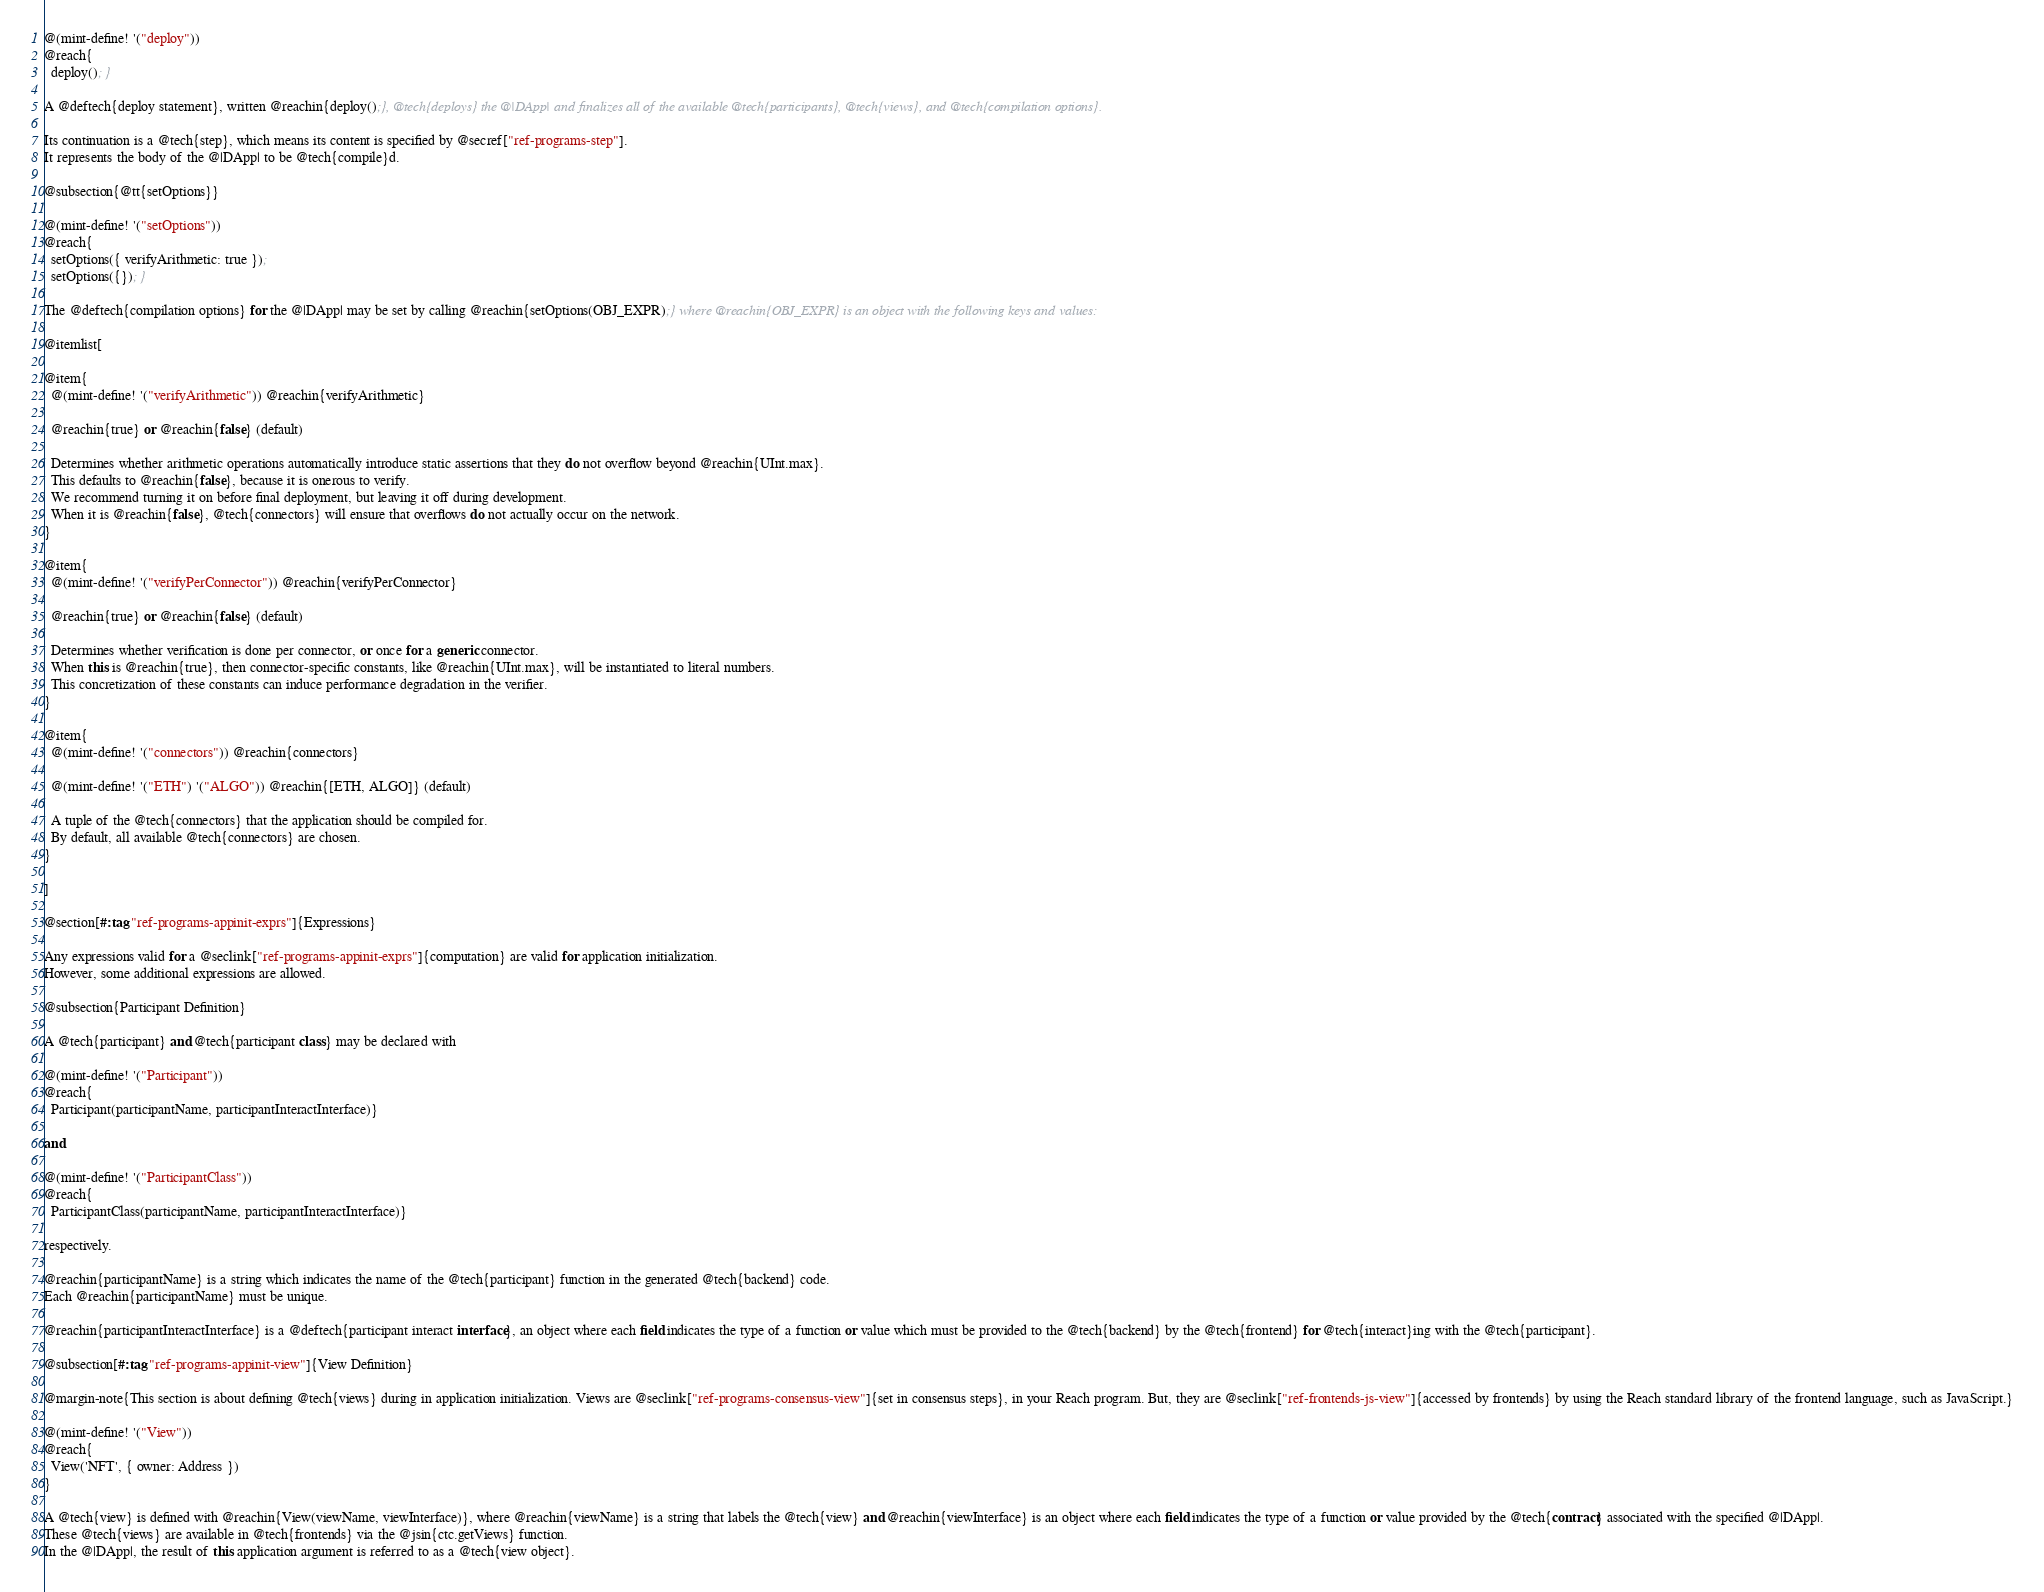Convert code to text. <code><loc_0><loc_0><loc_500><loc_500><_Racket_>@(mint-define! '("deploy"))
@reach{
  deploy(); }

A @deftech{deploy statement}, written @reachin{deploy();}, @tech{deploys} the @|DApp| and finalizes all of the available @tech{participants}, @tech{views}, and @tech{compilation options}.

Its continuation is a @tech{step}, which means its content is specified by @secref["ref-programs-step"].
It represents the body of the @|DApp| to be @tech{compile}d.

@subsection{@tt{setOptions}}

@(mint-define! '("setOptions"))
@reach{
  setOptions({ verifyArithmetic: true });
  setOptions({}); }

The @deftech{compilation options} for the @|DApp| may be set by calling @reachin{setOptions(OBJ_EXPR);} where @reachin{OBJ_EXPR} is an object with the following keys and values:

@itemlist[

@item{
  @(mint-define! '("verifyArithmetic")) @reachin{verifyArithmetic}

  @reachin{true} or @reachin{false} (default)

  Determines whether arithmetic operations automatically introduce static assertions that they do not overflow beyond @reachin{UInt.max}.
  This defaults to @reachin{false}, because it is onerous to verify.
  We recommend turning it on before final deployment, but leaving it off during development.
  When it is @reachin{false}, @tech{connectors} will ensure that overflows do not actually occur on the network.
}

@item{
  @(mint-define! '("verifyPerConnector")) @reachin{verifyPerConnector}

  @reachin{true} or @reachin{false} (default)

  Determines whether verification is done per connector, or once for a generic connector.
  When this is @reachin{true}, then connector-specific constants, like @reachin{UInt.max}, will be instantiated to literal numbers.
  This concretization of these constants can induce performance degradation in the verifier.
}

@item{
  @(mint-define! '("connectors")) @reachin{connectors}

  @(mint-define! '("ETH") '("ALGO")) @reachin{[ETH, ALGO]} (default)

  A tuple of the @tech{connectors} that the application should be compiled for.
  By default, all available @tech{connectors} are chosen.
}

]

@section[#:tag "ref-programs-appinit-exprs"]{Expressions}

Any expressions valid for a @seclink["ref-programs-appinit-exprs"]{computation} are valid for application initialization.
However, some additional expressions are allowed.

@subsection{Participant Definition}

A @tech{participant} and @tech{participant class} may be declared with

@(mint-define! '("Participant"))
@reach{
  Participant(participantName, participantInteractInterface)}

and

@(mint-define! '("ParticipantClass"))
@reach{
  ParticipantClass(participantName, participantInteractInterface)}

respectively.

@reachin{participantName} is a string which indicates the name of the @tech{participant} function in the generated @tech{backend} code.
Each @reachin{participantName} must be unique.

@reachin{participantInteractInterface} is a @deftech{participant interact interface}, an object where each field indicates the type of a function or value which must be provided to the @tech{backend} by the @tech{frontend} for @tech{interact}ing with the @tech{participant}.

@subsection[#:tag "ref-programs-appinit-view"]{View Definition}

@margin-note{This section is about defining @tech{views} during in application initialization. Views are @seclink["ref-programs-consensus-view"]{set in consensus steps}, in your Reach program. But, they are @seclink["ref-frontends-js-view"]{accessed by frontends} by using the Reach standard library of the frontend language, such as JavaScript.}

@(mint-define! '("View"))
@reach{
  View('NFT', { owner: Address })
}

A @tech{view} is defined with @reachin{View(viewName, viewInterface)}, where @reachin{viewName} is a string that labels the @tech{view} and @reachin{viewInterface} is an object where each field indicates the type of a function or value provided by the @tech{contract} associated with the specified @|DApp|.
These @tech{views} are available in @tech{frontends} via the @jsin{ctc.getViews} function.
In the @|DApp|, the result of this application argument is referred to as a @tech{view object}.

</code> 